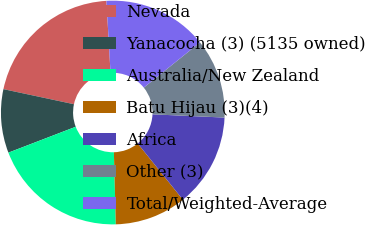<chart> <loc_0><loc_0><loc_500><loc_500><pie_chart><fcel>Nevada<fcel>Yanacocha (3) (5135 owned)<fcel>Australia/New Zealand<fcel>Batu Hijau (3)(4)<fcel>Africa<fcel>Other (3)<fcel>Total/Weighted-Average<nl><fcel>20.74%<fcel>9.19%<fcel>19.59%<fcel>10.35%<fcel>13.5%<fcel>11.5%<fcel>15.13%<nl></chart> 